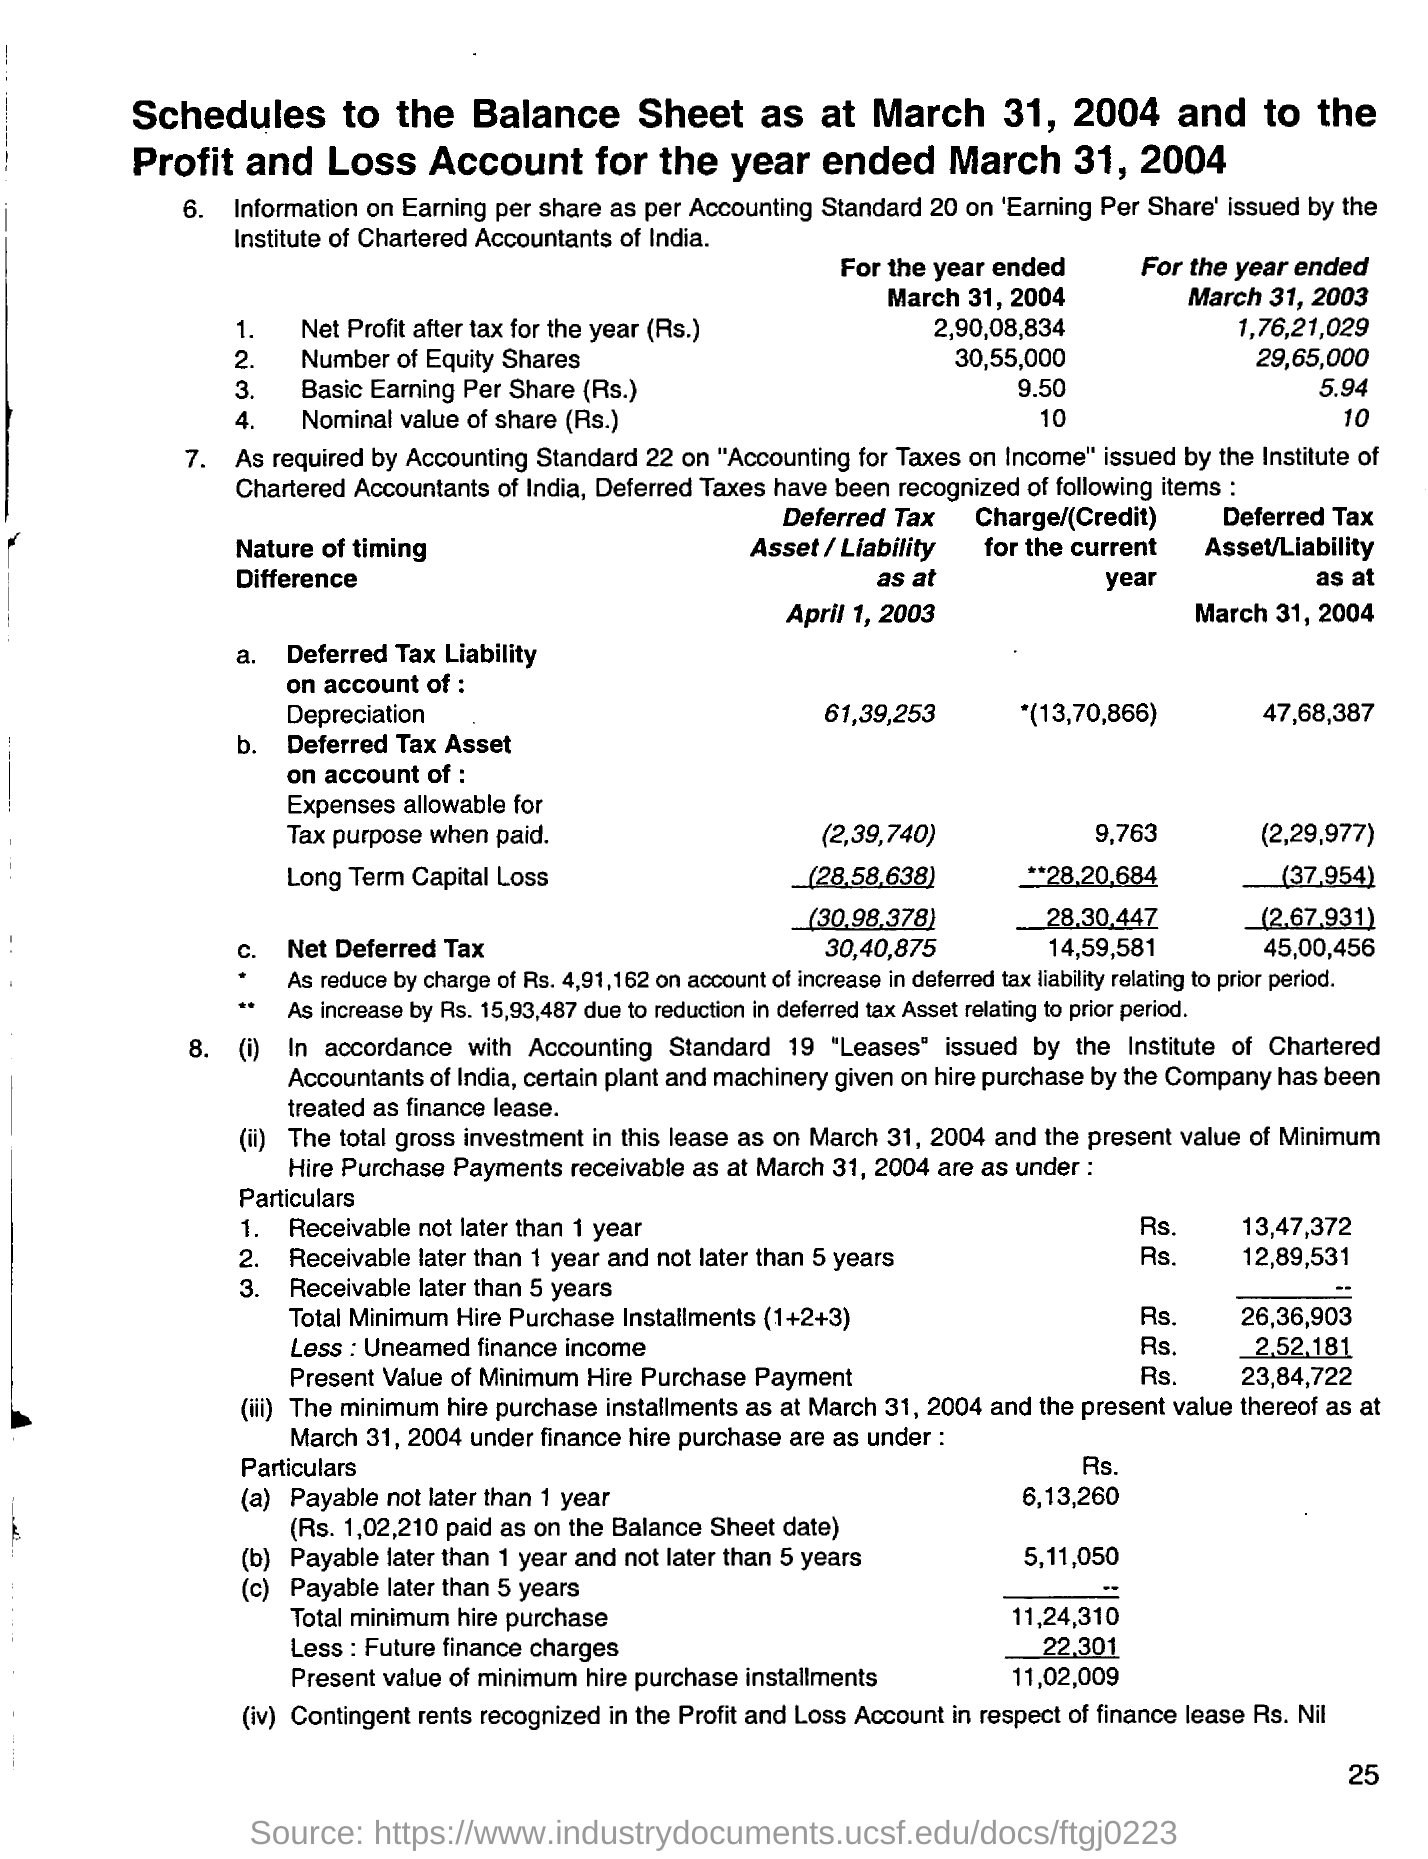Specify some key components in this picture. The deferred tax liability on account of depreciation as at April 1, 2003 is Rs. 61,39,253. The net profit after tax for the year ended March 31, 2004 was 2,90,08,834. The nominal value of the share for the year ended March 31, 2004 was Rs.10. The net profit after tax for the year ended March 31, 2003, was 1,76,21,029. The deferred tax liability on account of depreciation as of March 31, 2004 is 47,68,387. 